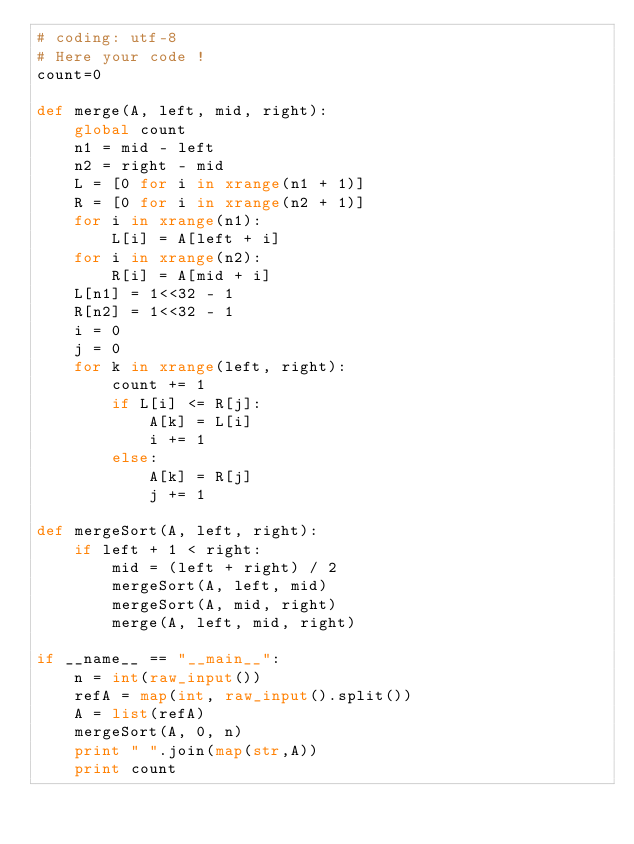Convert code to text. <code><loc_0><loc_0><loc_500><loc_500><_Python_># coding: utf-8
# Here your code !
count=0

def merge(A, left, mid, right):
    global count
    n1 = mid - left
    n2 = right - mid
    L = [0 for i in xrange(n1 + 1)]
    R = [0 for i in xrange(n2 + 1)]
    for i in xrange(n1):
        L[i] = A[left + i]
    for i in xrange(n2):
        R[i] = A[mid + i]
    L[n1] = 1<<32 - 1
    R[n2] = 1<<32 - 1
    i = 0
    j = 0
    for k in xrange(left, right):
        count += 1
        if L[i] <= R[j]:
            A[k] = L[i]
            i += 1
        else:
            A[k] = R[j]
            j += 1

def mergeSort(A, left, right):
    if left + 1 < right:
        mid = (left + right) / 2
        mergeSort(A, left, mid)
        mergeSort(A, mid, right)
        merge(A, left, mid, right)
        
if __name__ == "__main__":
    n = int(raw_input())
    refA = map(int, raw_input().split())
    A = list(refA)
    mergeSort(A, 0, n)
    print " ".join(map(str,A))
    print count </code> 